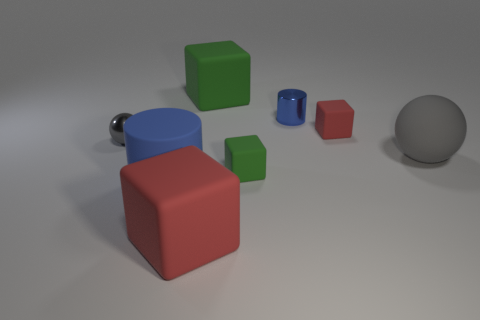Can you describe the lighting and shadows in this scene? The scene is lit from above, creating soft diffuse shadows on the ground beneath each object. The lighting suggests an even, possibly studio-like environment, given the uniformity and soft edges of the shadows. 